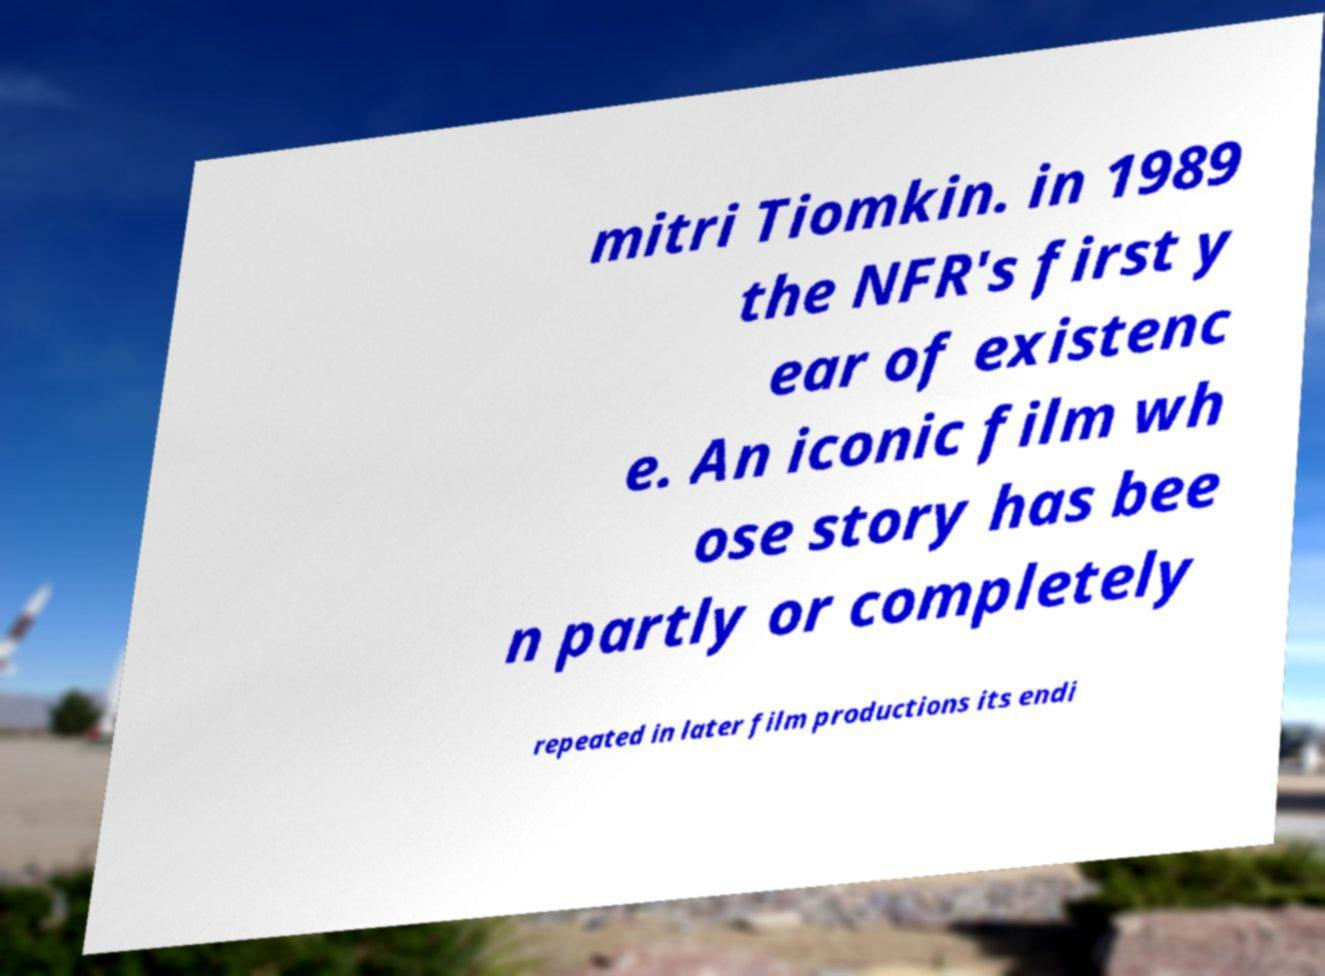Please read and relay the text visible in this image. What does it say? mitri Tiomkin. in 1989 the NFR's first y ear of existenc e. An iconic film wh ose story has bee n partly or completely repeated in later film productions its endi 